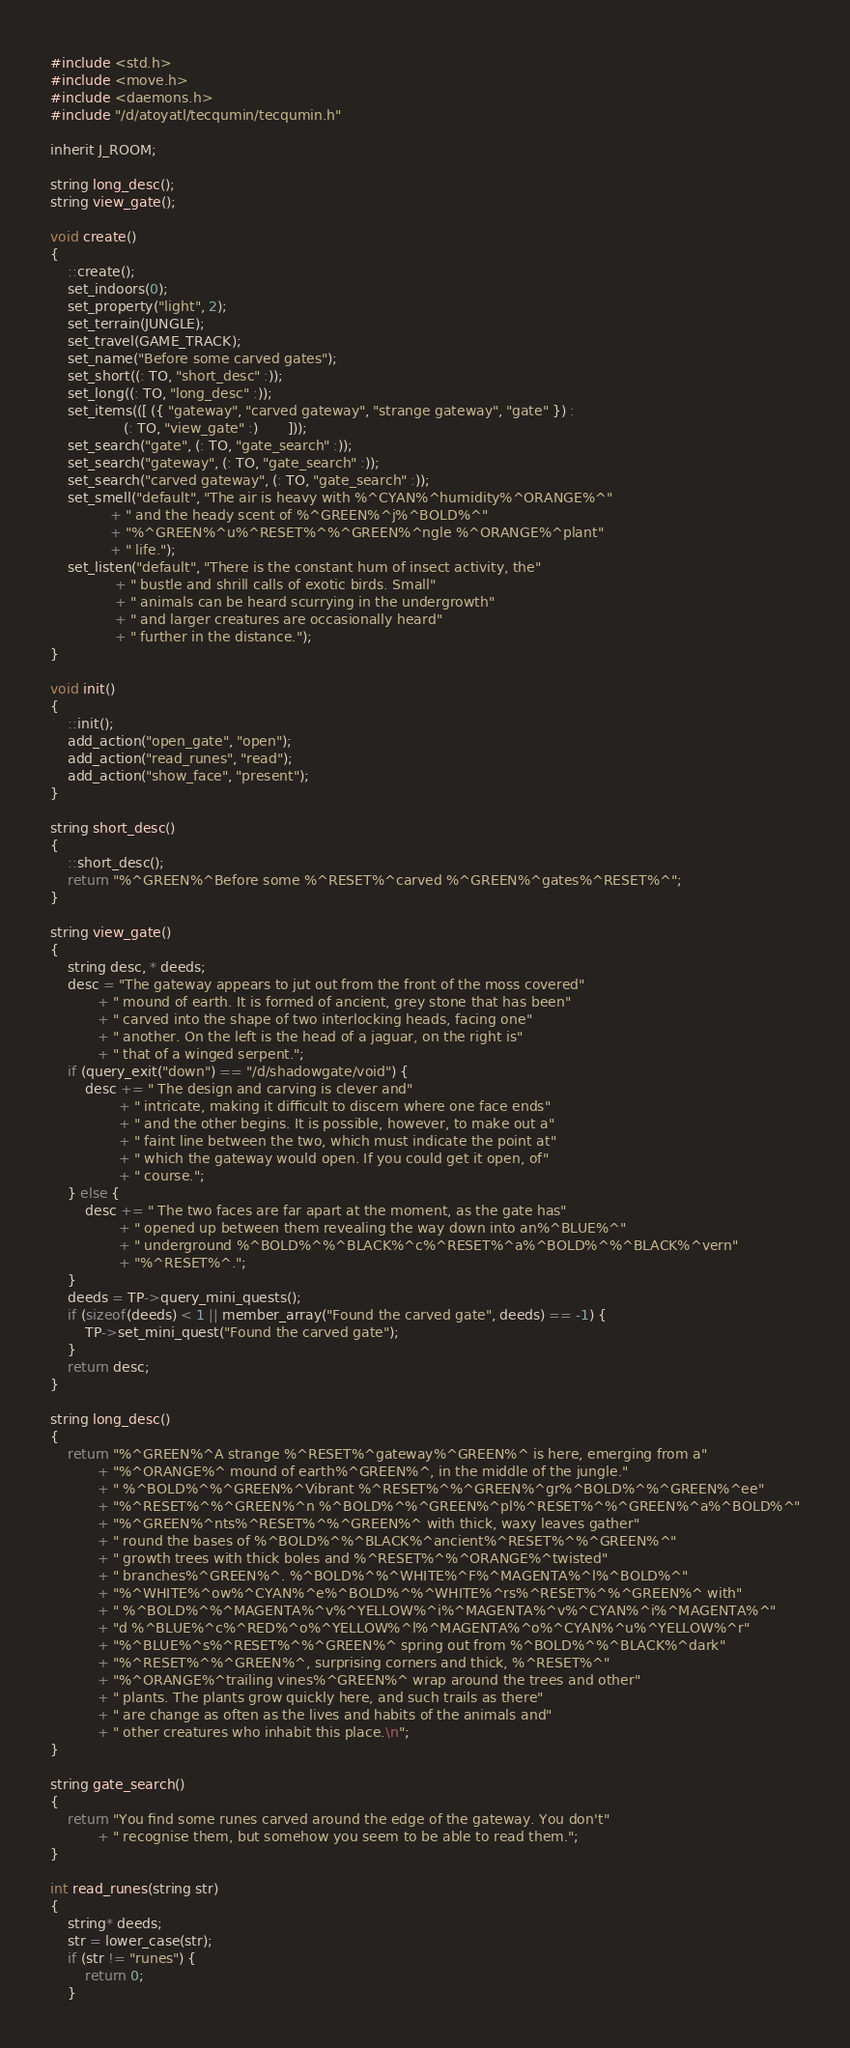Convert code to text. <code><loc_0><loc_0><loc_500><loc_500><_C_>#include <std.h>
#include <move.h>
#include <daemons.h>
#include "/d/atoyatl/tecqumin/tecqumin.h"

inherit J_ROOM;

string long_desc();
string view_gate();

void create()
{
    ::create();
    set_indoors(0);
    set_property("light", 2);
    set_terrain(JUNGLE);
    set_travel(GAME_TRACK);
    set_name("Before some carved gates");
    set_short((: TO, "short_desc" :));
    set_long((: TO, "long_desc" :));
    set_items(([ ({ "gateway", "carved gateway", "strange gateway", "gate" }) :
                 (: TO, "view_gate" :)       ]));
    set_search("gate", (: TO, "gate_search" :));
    set_search("gateway", (: TO, "gate_search" :));
    set_search("carved gateway", (: TO, "gate_search" :));
    set_smell("default", "The air is heavy with %^CYAN%^humidity%^ORANGE%^"
              + " and the heady scent of %^GREEN%^j%^BOLD%^"
              + "%^GREEN%^u%^RESET%^%^GREEN%^ngle %^ORANGE%^plant"
              + " life.");
    set_listen("default", "There is the constant hum of insect activity, the"
               + " bustle and shrill calls of exotic birds. Small"
               + " animals can be heard scurrying in the undergrowth"
               + " and larger creatures are occasionally heard"
               + " further in the distance.");
}

void init()
{
    ::init();
    add_action("open_gate", "open");
    add_action("read_runes", "read");
    add_action("show_face", "present");
}

string short_desc()
{
    ::short_desc();
    return "%^GREEN%^Before some %^RESET%^carved %^GREEN%^gates%^RESET%^";
}

string view_gate()
{
    string desc, * deeds;
    desc = "The gateway appears to jut out from the front of the moss covered"
           + " mound of earth. It is formed of ancient, grey stone that has been"
           + " carved into the shape of two interlocking heads, facing one"
           + " another. On the left is the head of a jaguar, on the right is"
           + " that of a winged serpent.";
    if (query_exit("down") == "/d/shadowgate/void") {
        desc += " The design and carving is clever and"
                + " intricate, making it difficult to discern where one face ends"
                + " and the other begins. It is possible, however, to make out a"
                + " faint line between the two, which must indicate the point at"
                + " which the gateway would open. If you could get it open, of"
                + " course.";
    } else {
        desc += " The two faces are far apart at the moment, as the gate has"
                + " opened up between them revealing the way down into an%^BLUE%^"
                + " underground %^BOLD%^%^BLACK%^c%^RESET%^a%^BOLD%^%^BLACK%^vern"
                + "%^RESET%^.";
    }
    deeds = TP->query_mini_quests();
    if (sizeof(deeds) < 1 || member_array("Found the carved gate", deeds) == -1) {
        TP->set_mini_quest("Found the carved gate");
    }
    return desc;
}

string long_desc()
{
    return "%^GREEN%^A strange %^RESET%^gateway%^GREEN%^ is here, emerging from a"
           + "%^ORANGE%^ mound of earth%^GREEN%^, in the middle of the jungle."
           + " %^BOLD%^%^GREEN%^Vibrant %^RESET%^%^GREEN%^gr%^BOLD%^%^GREEN%^ee"
           + "%^RESET%^%^GREEN%^n %^BOLD%^%^GREEN%^pl%^RESET%^%^GREEN%^a%^BOLD%^"
           + "%^GREEN%^nts%^RESET%^%^GREEN%^ with thick, waxy leaves gather"
           + " round the bases of %^BOLD%^%^BLACK%^ancient%^RESET%^%^GREEN%^"
           + " growth trees with thick boles and %^RESET%^%^ORANGE%^twisted"
           + " branches%^GREEN%^. %^BOLD%^%^WHITE%^F%^MAGENTA%^l%^BOLD%^"
           + "%^WHITE%^ow%^CYAN%^e%^BOLD%^%^WHITE%^rs%^RESET%^%^GREEN%^ with"
           + " %^BOLD%^%^MAGENTA%^v%^YELLOW%^i%^MAGENTA%^v%^CYAN%^i%^MAGENTA%^"
           + "d %^BLUE%^c%^RED%^o%^YELLOW%^l%^MAGENTA%^o%^CYAN%^u%^YELLOW%^r"
           + "%^BLUE%^s%^RESET%^%^GREEN%^ spring out from %^BOLD%^%^BLACK%^dark"
           + "%^RESET%^%^GREEN%^, surprising corners and thick, %^RESET%^"
           + "%^ORANGE%^trailing vines%^GREEN%^ wrap around the trees and other"
           + " plants. The plants grow quickly here, and such trails as there"
           + " are change as often as the lives and habits of the animals and"
           + " other creatures who inhabit this place.\n";
}

string gate_search()
{
    return "You find some runes carved around the edge of the gateway. You don't"
           + " recognise them, but somehow you seem to be able to read them.";
}

int read_runes(string str)
{
    string* deeds;
    str = lower_case(str);
    if (str != "runes") {
        return 0;
    }</code> 